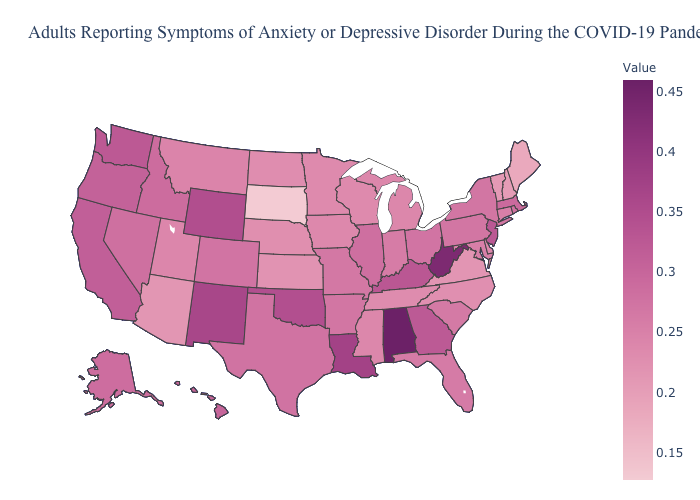Does South Dakota have the lowest value in the USA?
Quick response, please. Yes. Does New York have the highest value in the Northeast?
Keep it brief. No. Among the states that border Georgia , does North Carolina have the lowest value?
Concise answer only. Yes. Does Kentucky have a lower value than Louisiana?
Quick response, please. Yes. 